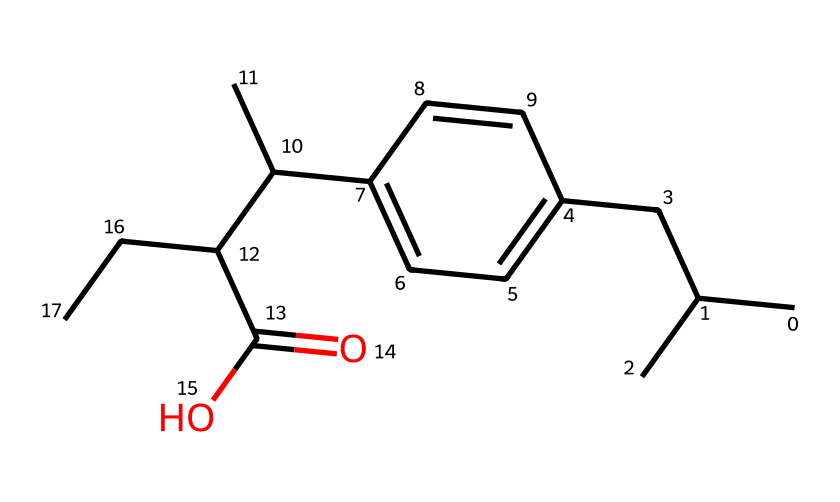What is the main functional group present in this chemical? The functional group can be identified by looking for characteristic structures in the chemical. In this case, the presence of a carboxylic acid group (-COOH) is indicated by the terminal part of the chemical structure where there is a carbon (C) double bonded to an oxygen (O) and single bonded to a hydroxyl group (OH).
Answer: carboxylic acid How many carbon atoms are in this molecule? The carbon atoms can be counted by inspecting the SMILES representation. Each capital 'C' represents a carbon atom, and those in the branches and the functional group also count. By carefully reviewing the structure, there are a total of 15 carbon atoms present.
Answer: 15 What type of drug is this compound commonly classified as? This compound is commonly classified as a nonsteroidal anti-inflammatory drug (NSAID). This classification is based on its chemical structure which suggests it inhibits certain pathways leading to inflammation and pain, common for over-the-counter pain relievers like ibuprofen.
Answer: NSAID Does this chemical contain any aromatic rings? The presence of aromatic rings can be determined by looking for cycles of carbon atoms with alternating double bonds, typically denoted by the presence of 'C' and '=' in the SMILES. This structure shows a benzene ring based on the six-membered cyclic part highlighted in the chemical.
Answer: yes What is the molecular formula of this compound? To derive the molecular formula, the number of each type of atom present in the molecule can be counted directly from the SMILES notation. In this case, the breakdown shows C15H22O2, representing 15 carbons, 22 hydrogens, and 2 oxygens.
Answer: C15H22O2 Which property does the presence of the hydroxyl group (-OH) contribute to this chemical? The hydroxyl group contributes to the polarity of the molecule, making it more soluble in water compared to non-polar substances. This is significant for pharmacology as it affects the drug's absorption and distribution in the body.
Answer: solubility 